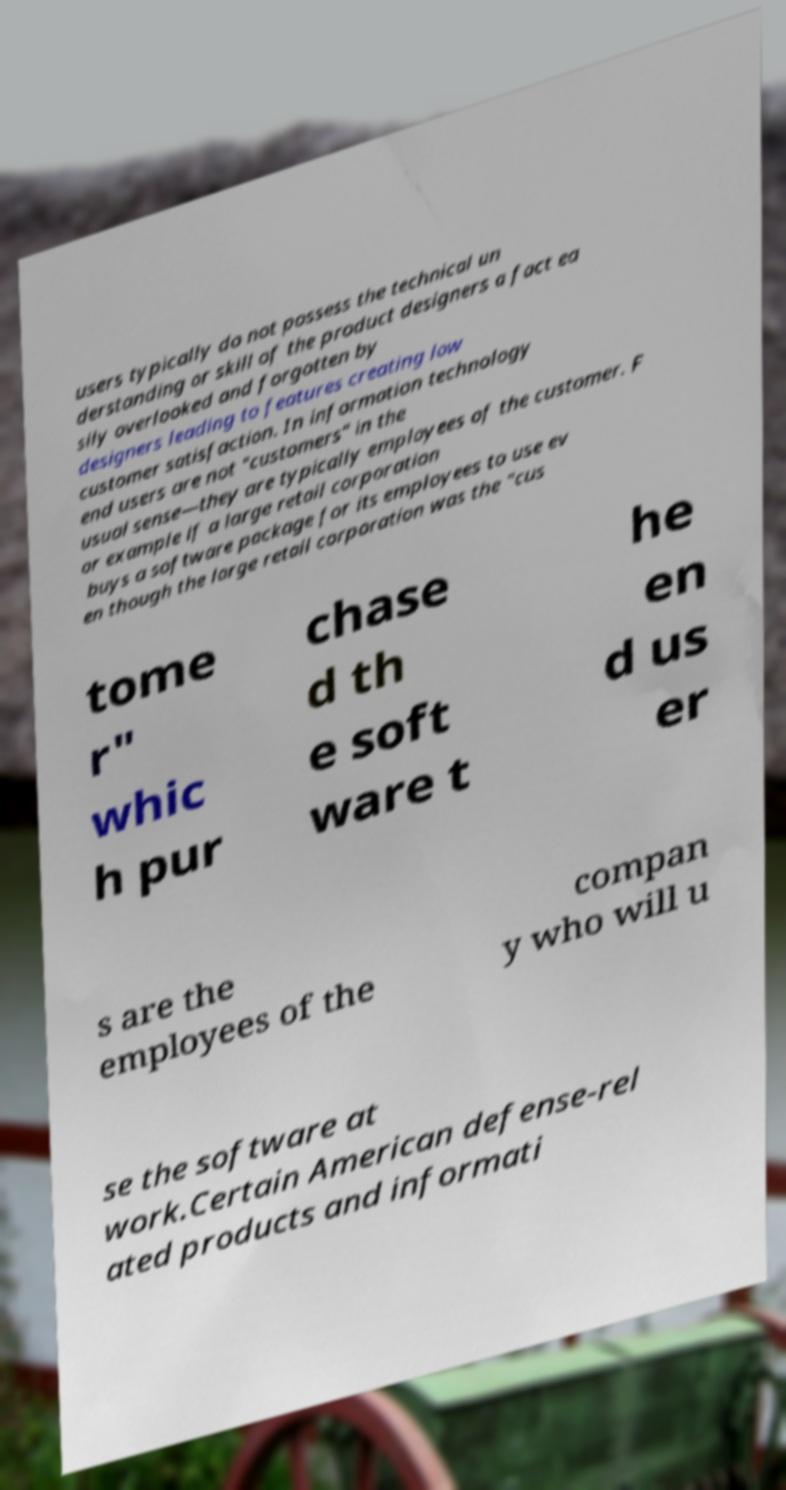Could you extract and type out the text from this image? users typically do not possess the technical un derstanding or skill of the product designers a fact ea sily overlooked and forgotten by designers leading to features creating low customer satisfaction. In information technology end users are not "customers" in the usual sense—they are typically employees of the customer. F or example if a large retail corporation buys a software package for its employees to use ev en though the large retail corporation was the "cus tome r" whic h pur chase d th e soft ware t he en d us er s are the employees of the compan y who will u se the software at work.Certain American defense-rel ated products and informati 